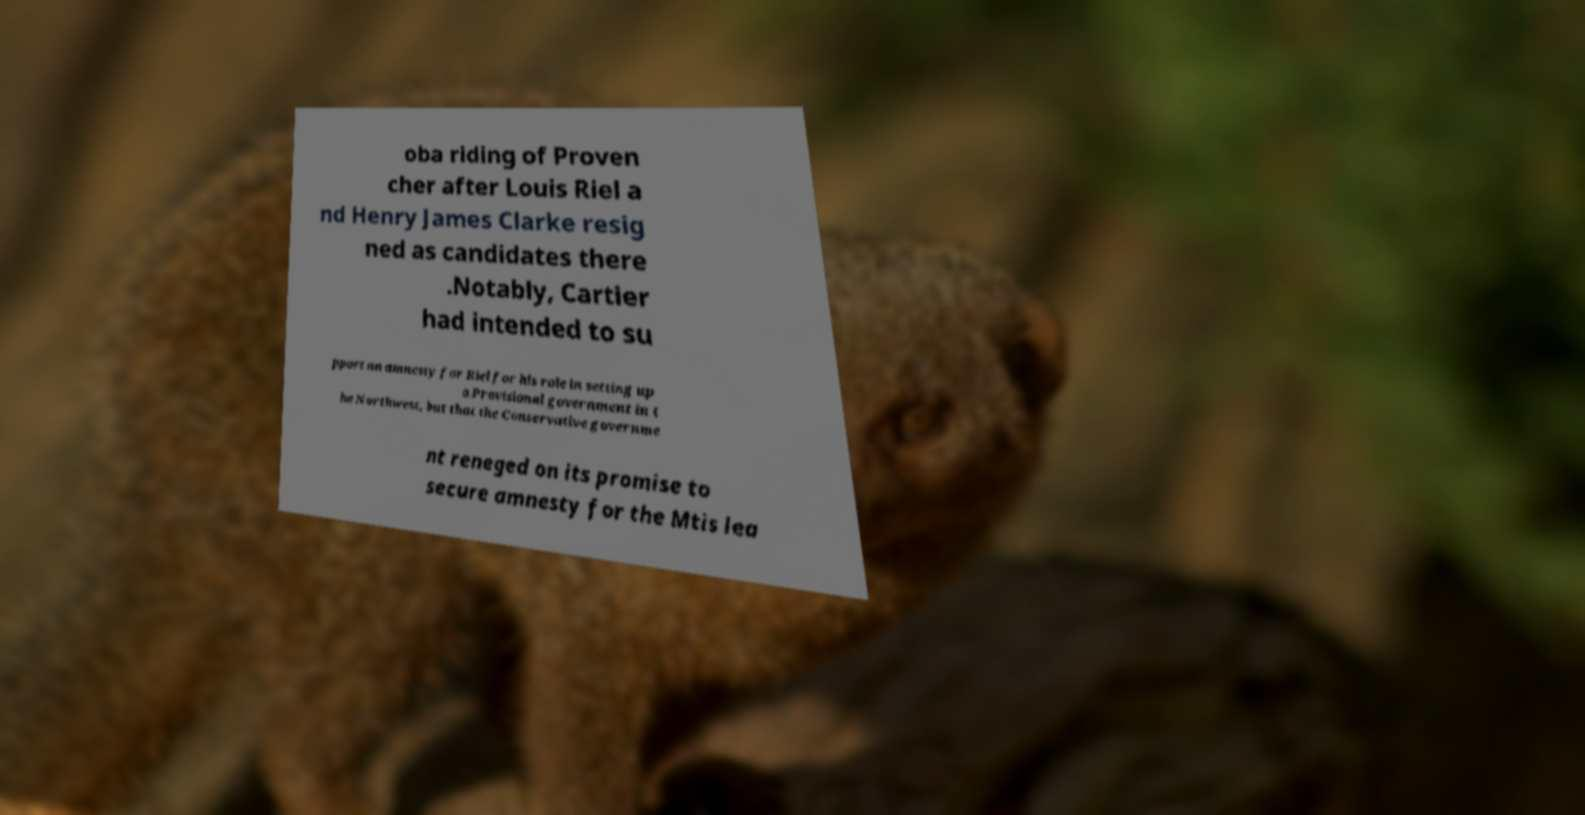For documentation purposes, I need the text within this image transcribed. Could you provide that? oba riding of Proven cher after Louis Riel a nd Henry James Clarke resig ned as candidates there .Notably, Cartier had intended to su pport an amnesty for Riel for his role in setting up a Provisional government in t he Northwest, but that the Conservative governme nt reneged on its promise to secure amnesty for the Mtis lea 